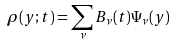Convert formula to latex. <formula><loc_0><loc_0><loc_500><loc_500>\rho ( y ; t ) = \sum _ { \nu } B _ { \nu } ( t ) \Psi _ { \nu } ( y )</formula> 